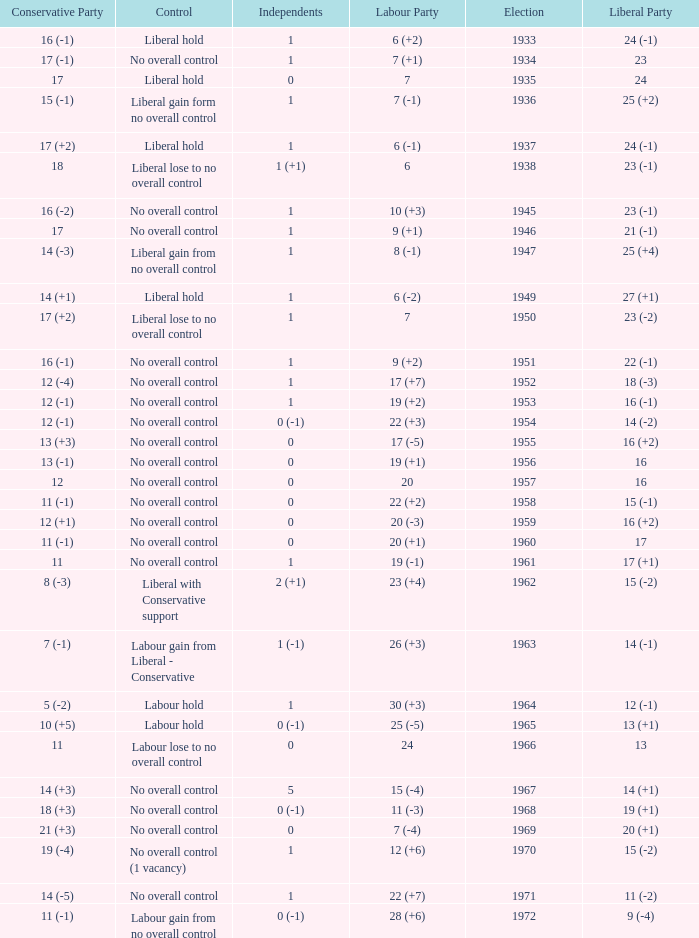Who was in control the year that Labour Party won 12 (+6) seats? No overall control (1 vacancy). 